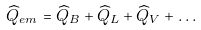Convert formula to latex. <formula><loc_0><loc_0><loc_500><loc_500>\widehat { Q } _ { e m } = \widehat { Q } _ { B } + \widehat { Q } _ { L } + \widehat { Q } _ { V } + \dots</formula> 